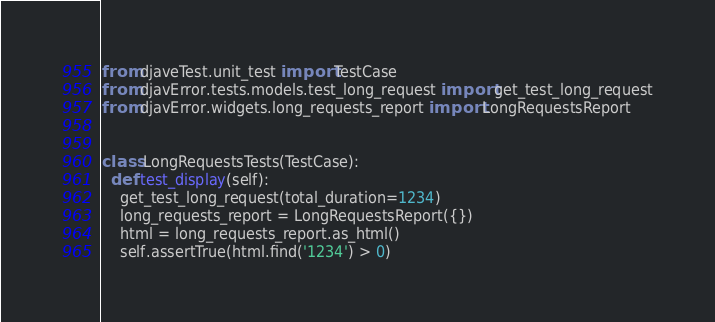<code> <loc_0><loc_0><loc_500><loc_500><_Python_>from djaveTest.unit_test import TestCase
from djavError.tests.models.test_long_request import get_test_long_request
from djavError.widgets.long_requests_report import LongRequestsReport


class LongRequestsTests(TestCase):
  def test_display(self):
    get_test_long_request(total_duration=1234)
    long_requests_report = LongRequestsReport({})
    html = long_requests_report.as_html()
    self.assertTrue(html.find('1234') > 0)
</code> 